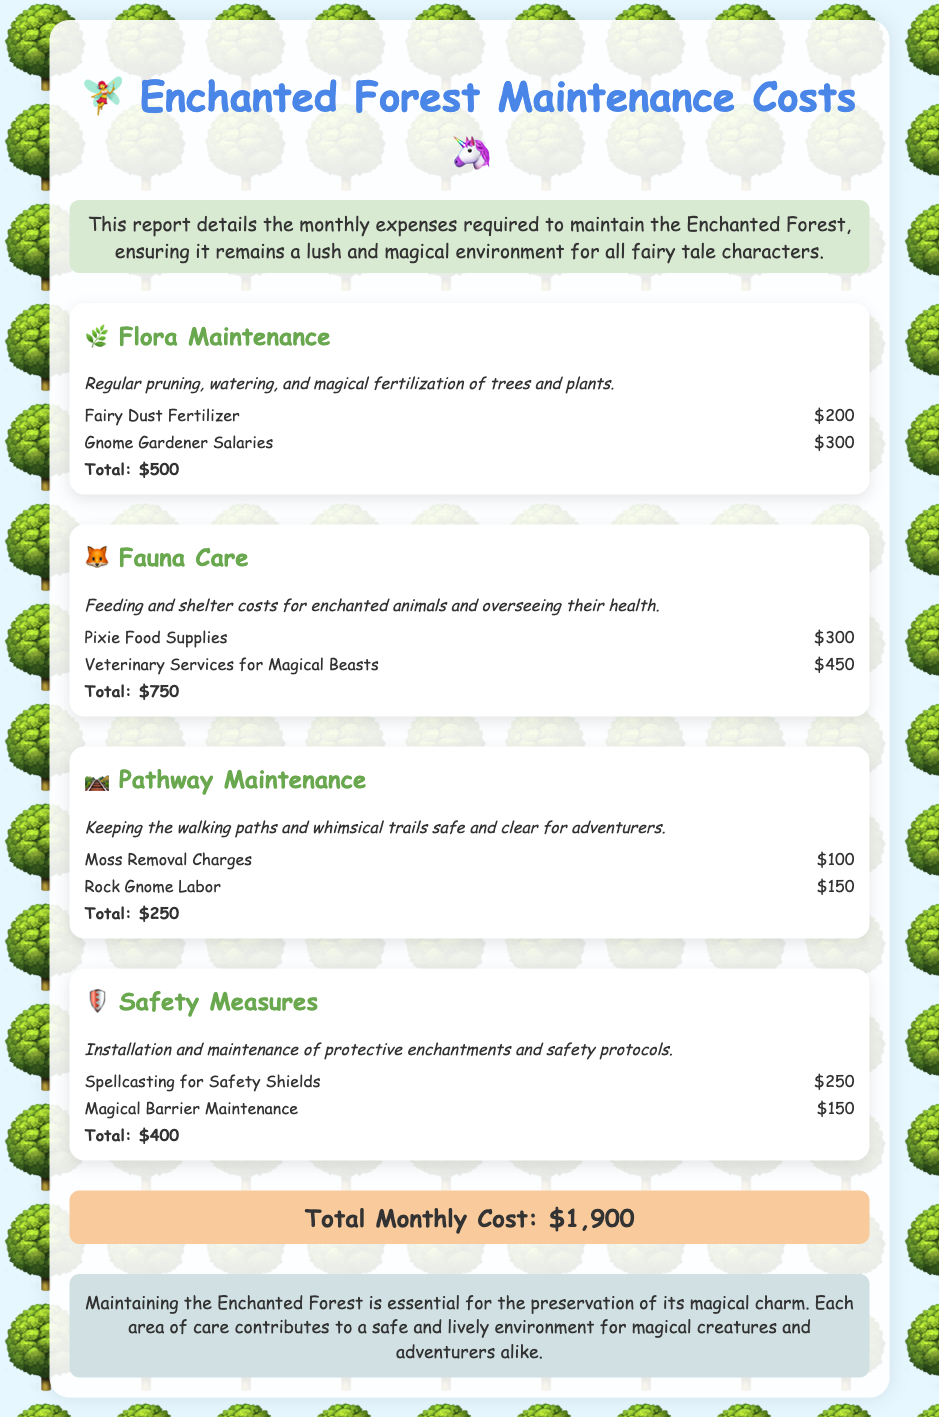What is the total cost for Flora Maintenance? The total cost for Flora Maintenance is the sum of all expenses related to flora, which is $200.00 + $300.00.
Answer: $500 How much does Pixie Food Supplies cost? The cost for Pixie Food Supplies, listed under Fauna Care, is specified directly in the document.
Answer: $300 What are the expenses for Safety Measures? The expenses for Safety Measures involve two items: Spellcasting for Safety Shields and Magical Barrier Maintenance, which total to $250.00 + $150.00.
Answer: $400 Which category has the highest total expenses? By comparing the total amounts for each category, it is clear which one has the most significant costs associated with it.
Answer: Fauna Care What is the total monthly cost for maintaining the Enchanted Forest? The total monthly cost is stated in the summary of the entire document, where all category totals are combined.
Answer: $1,900 How much do the Gnome Gardener Salaries cost? The cost is directly mentioned under the Flora Maintenance category.
Answer: $300 What is included in the Pathway Maintenance? Pathway Maintenance consists of two items, which involve costs for moss removal and labor by Rock Gnomes.
Answer: Moss Removal Charges and Rock Gnome Labor What kind of supplies are involved in Fauna Care? Supplies needed for Fauna Care primarily include food supplies for the pixies and veterinary services for magical beasts.
Answer: Pixie Food Supplies and Veterinary Services for Magical Beasts 